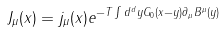Convert formula to latex. <formula><loc_0><loc_0><loc_500><loc_500>J _ { \mu } ( x ) = j _ { \mu } ( x ) e ^ { - T \int d ^ { d } y G _ { 0 } ( x - y ) \partial _ { \mu } B ^ { \mu } ( y ) }</formula> 